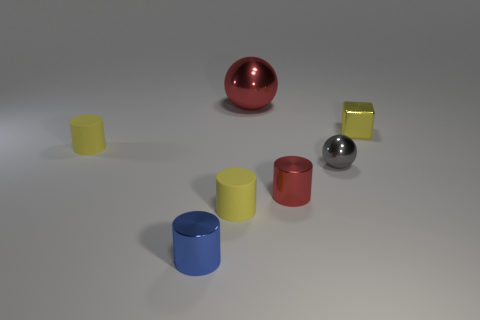Are there any patterns or consistencies in the arrangement of the objects? The objects are arranged with no apparent pattern in terms of shape, color, or material. However, there is a symmetry in the sense that there are two of each type of object: two spheres, two types of cylinders, and three cubes. The arrangement appears random but balanced, with the objects spread out over the surface, providing both a sense of variety and order. 